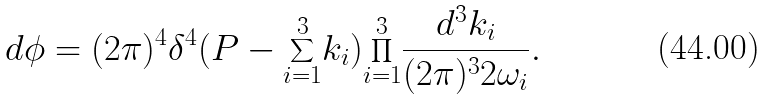<formula> <loc_0><loc_0><loc_500><loc_500>d \phi = ( 2 \pi ) ^ { 4 } \delta ^ { 4 } ( P - { \sum _ { i = 1 } ^ { 3 } } k _ { i } ) { \prod _ { i = 1 } ^ { 3 } } \frac { d ^ { 3 } k _ { i } } { ( 2 \pi ) ^ { 3 } 2 \omega _ { i } } .</formula> 